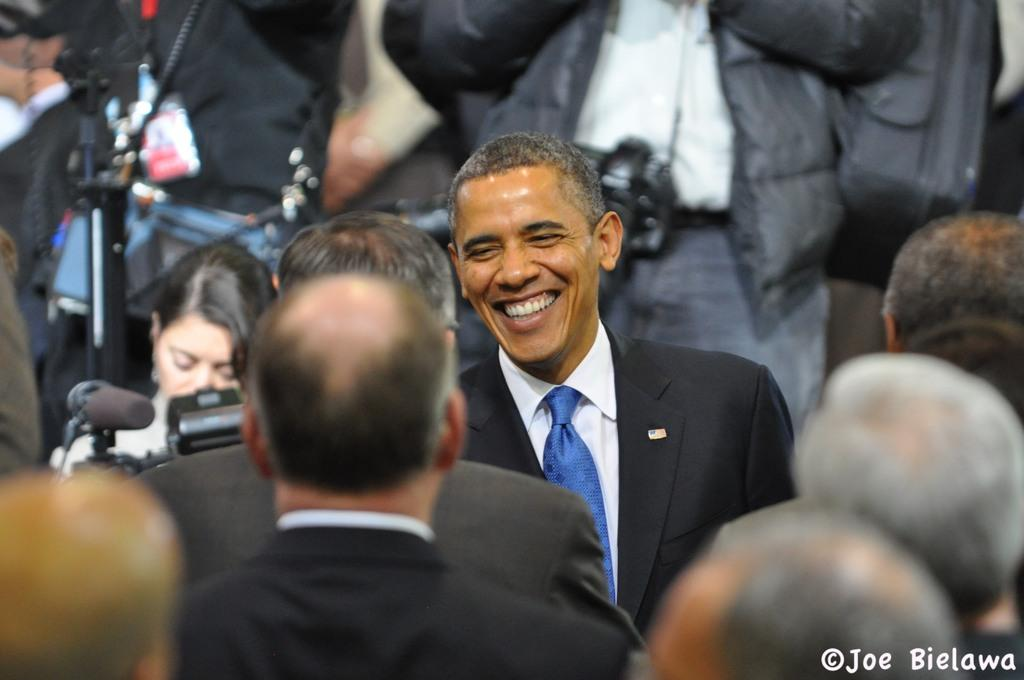Who is the main subject in the center of the image? There is Obama in the center of the image. What are the people around Obama doing? The people standing around Obama are likely observing or interacting with him. What equipment is present in the image? There are cameras and microphones present in the image. What can be found at the bottom of the image? There is some text at the bottom of the image. What type of destruction can be seen in the image? There is no destruction present in the image. 